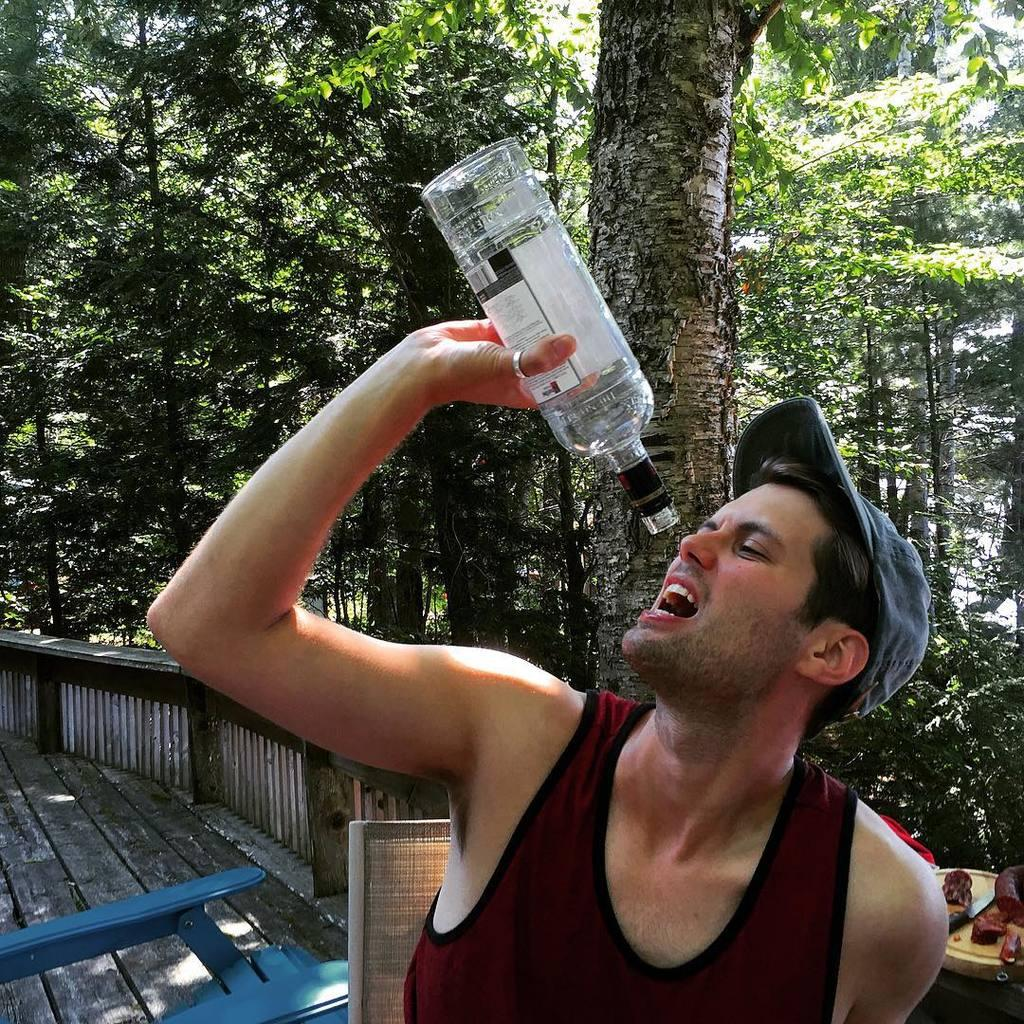Who is present in the image? There is a man in the image. What is the man holding in the image? The man is holding a bottle. What can be seen in the background of the image? There is a tree and the sky visible in the background of the image. Where is the pump located in the image? There is no pump present in the image. Can you see any frogs in the image? There are no frogs present in the image. 